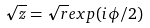<formula> <loc_0><loc_0><loc_500><loc_500>\sqrt { z } = \sqrt { r } e x p ( i \phi / 2 )</formula> 